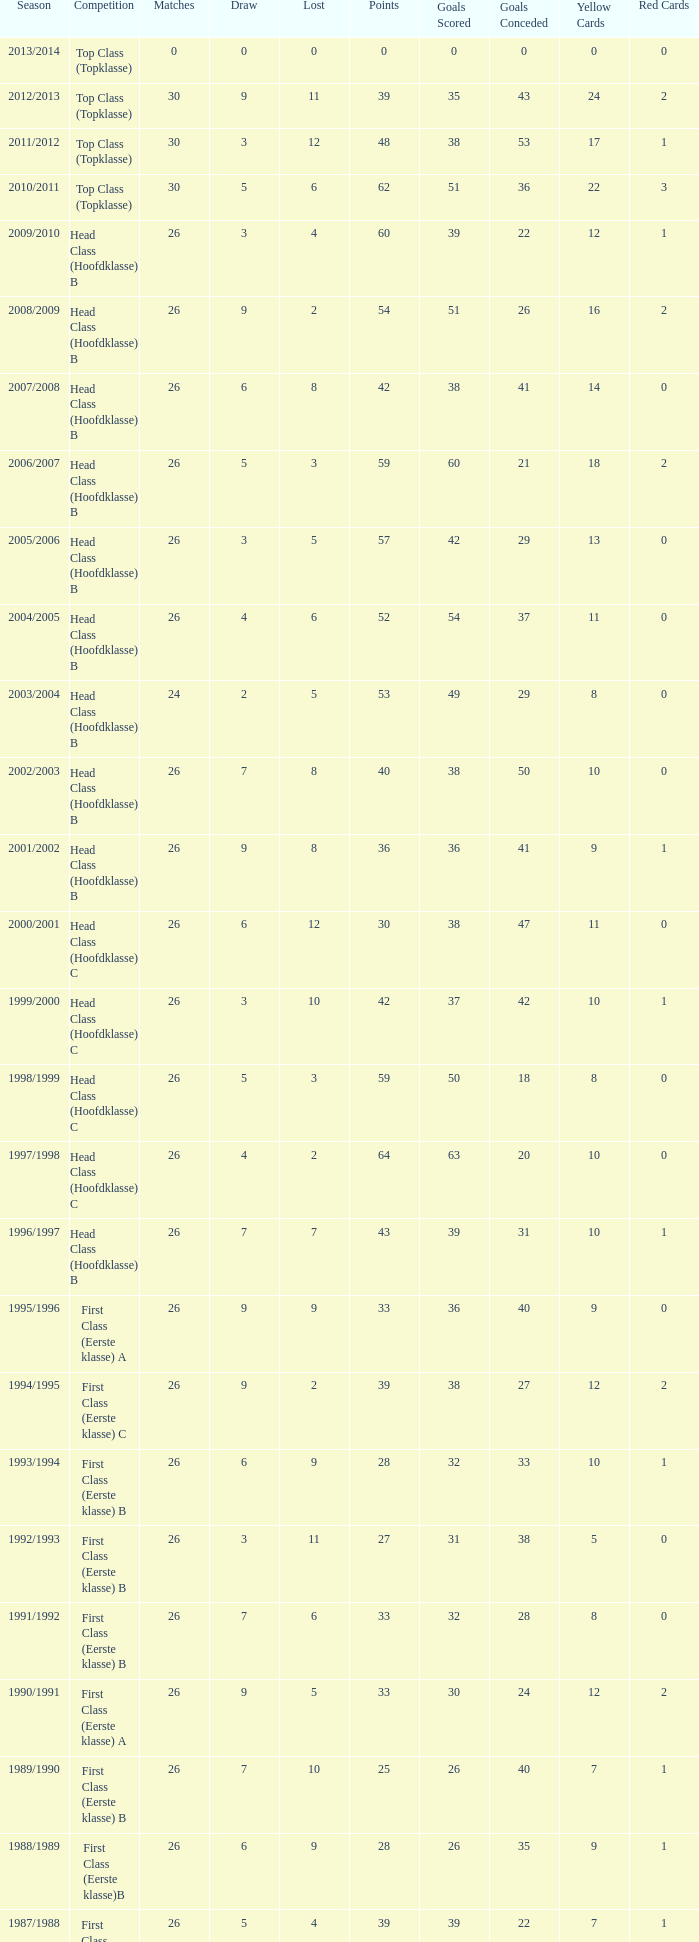What type of competition yields a score of over 30, less than 5 draws, and more than 10 losses? Top Class (Topklasse). 